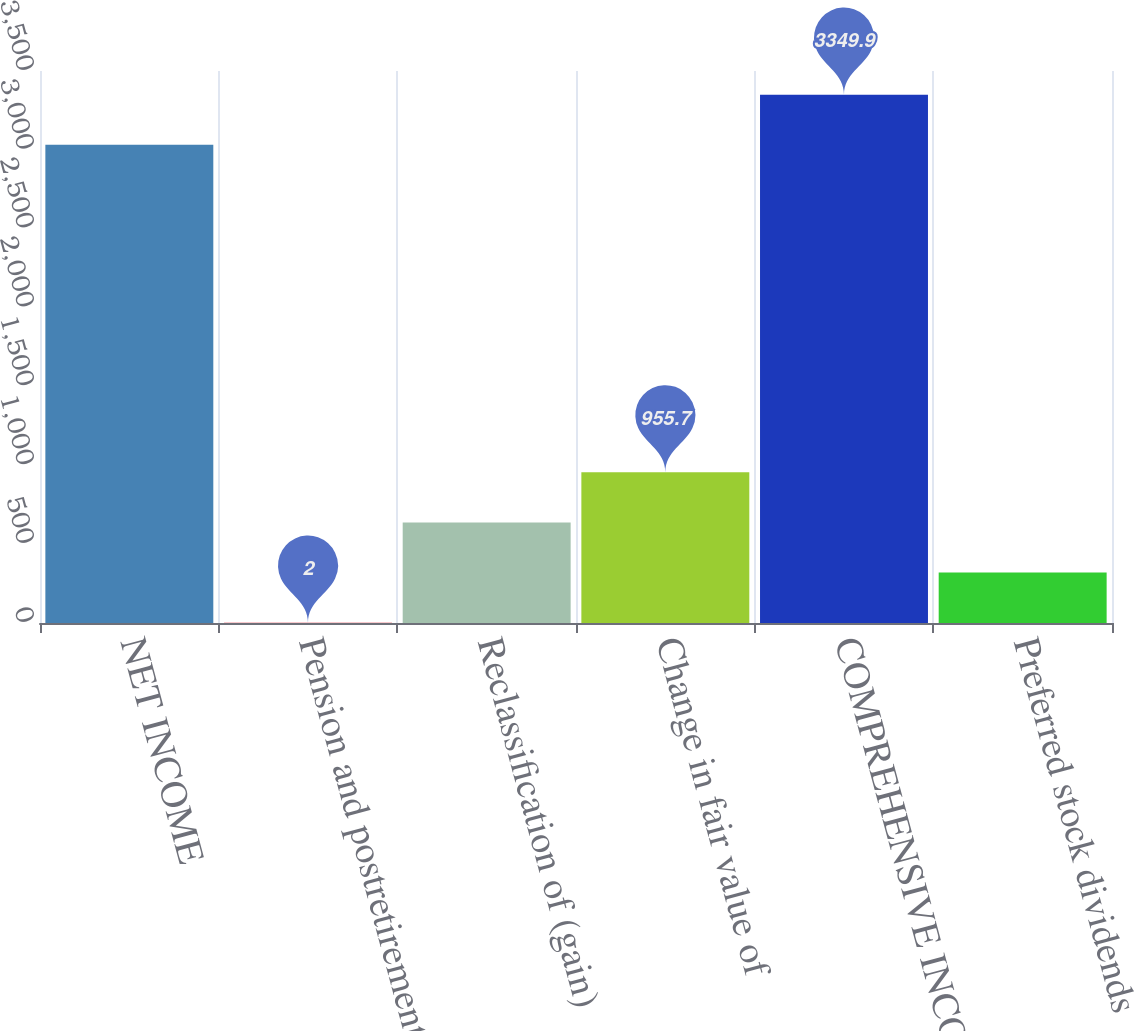Convert chart. <chart><loc_0><loc_0><loc_500><loc_500><bar_chart><fcel>NET INCOME<fcel>Pension and postretirement<fcel>Reclassification of (gain)<fcel>Change in fair value of<fcel>COMPREHENSIVE INCOME<fcel>Preferred stock dividends<nl><fcel>3032<fcel>2<fcel>637.8<fcel>955.7<fcel>3349.9<fcel>319.9<nl></chart> 